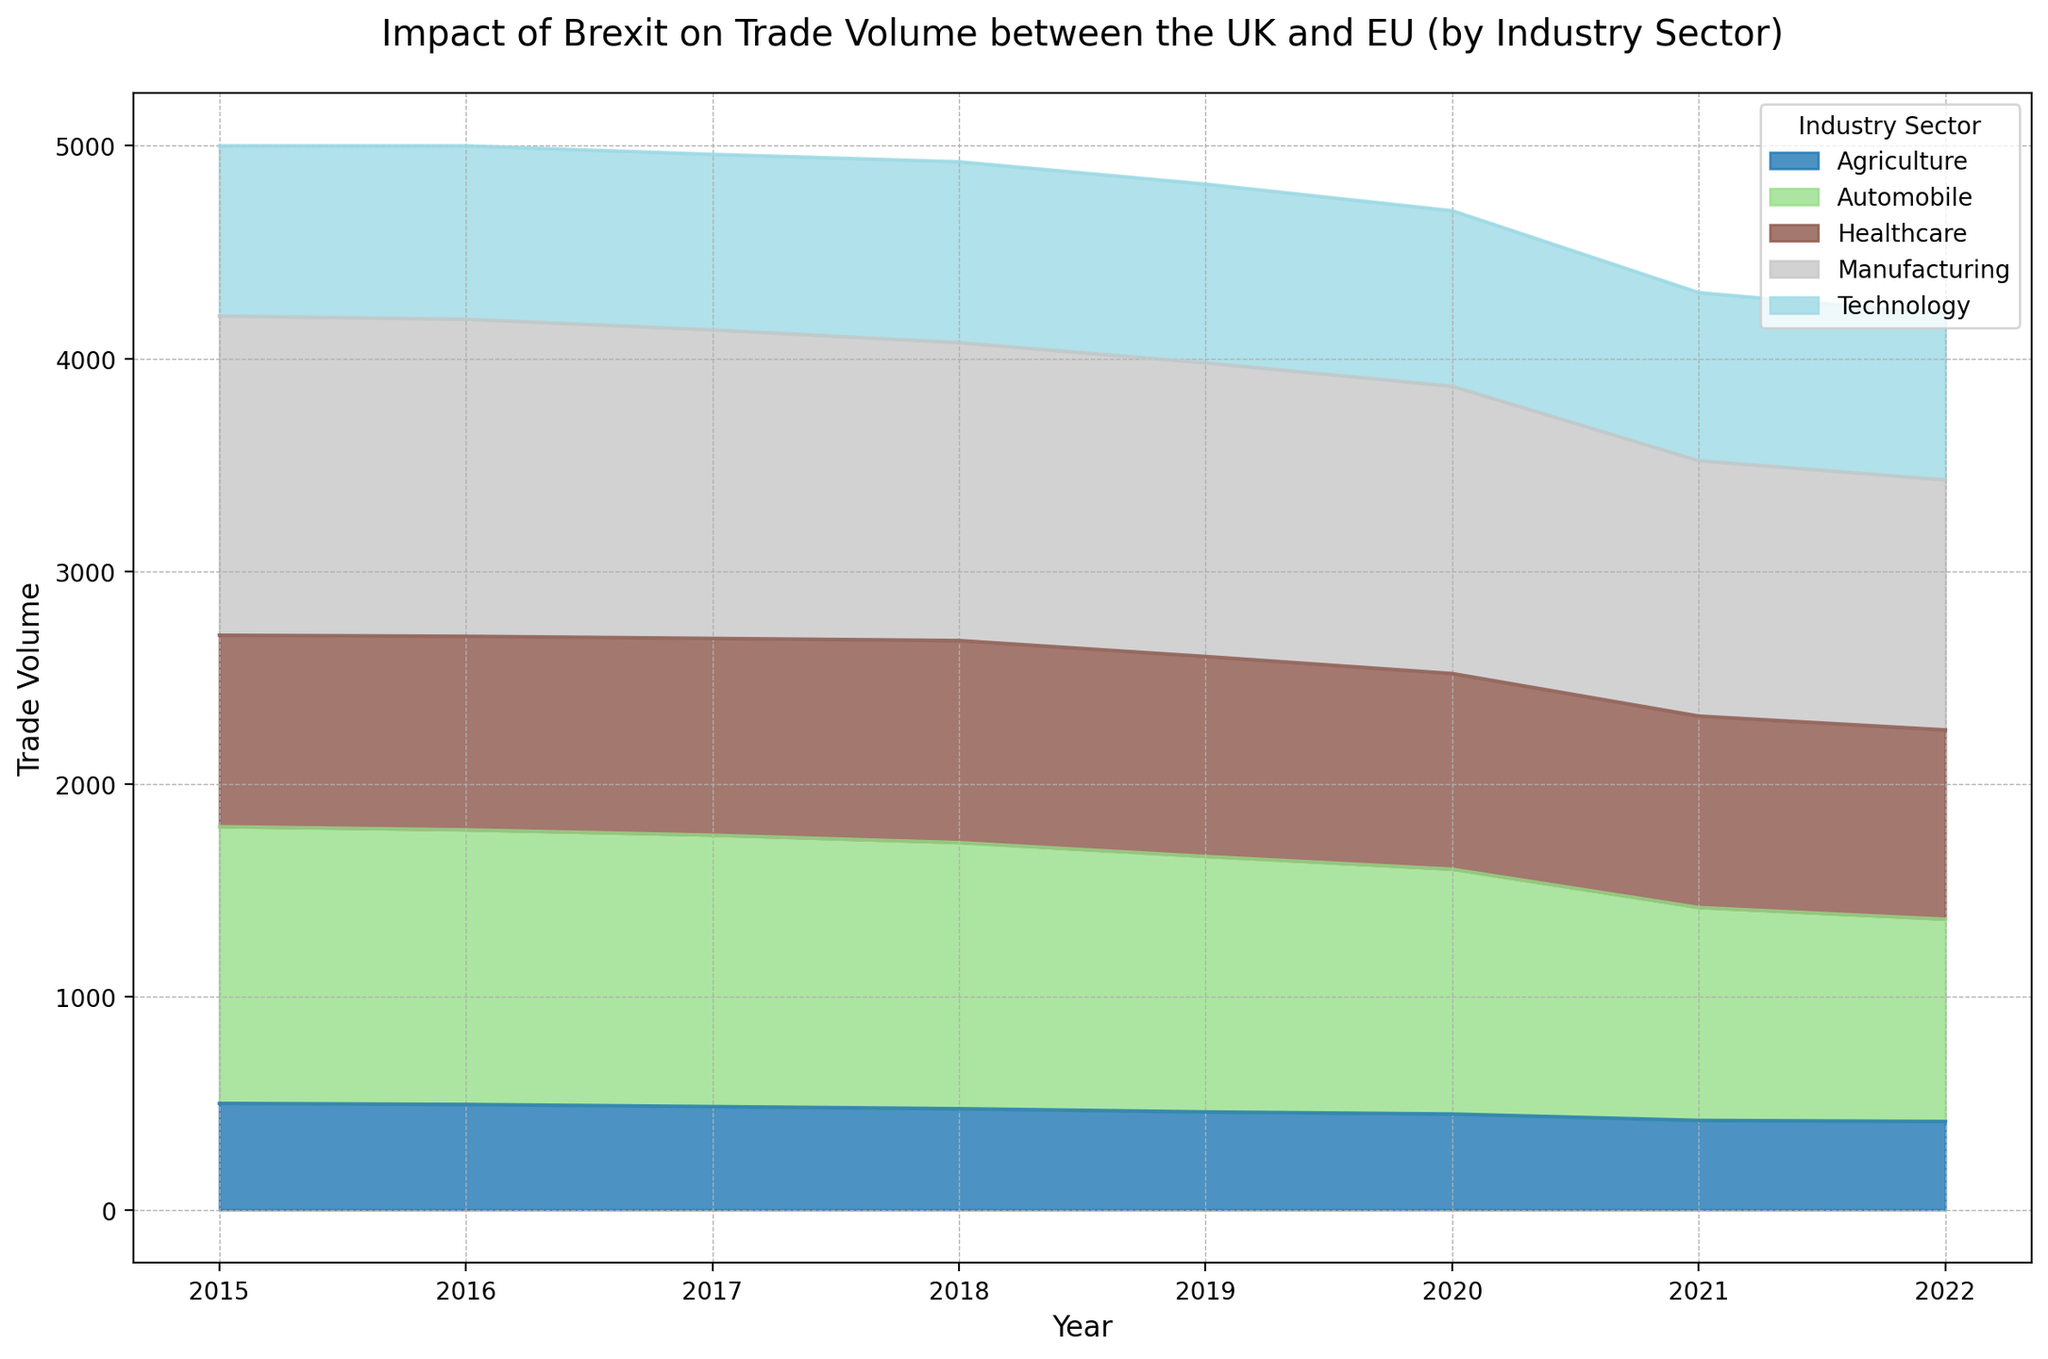What year did Agriculture experience the most significant drop in trade volume? Looking at the area representing Agriculture, the biggest drop occurs between 2020 and 2021. In 2020, the trade volume is 450, and in 2021 it drops to 420, a reduction of 30 units.
Answer: 2021 Which industry sector had the highest trade volume consistently over the years? By examining the cumulative height of the areas stacked in the chart, Manufacturing consistently appears on top, indicating it had the highest trade volume each year.
Answer: Manufacturing In which year did the Technology sector start to decline in trade volume? Observing the area chart for Technology, the trade volume starts to decline after 2019. The line decreases from 2019 to 2020.
Answer: 2020 What is the combined trade volume of Healthcare and Automobile sectors in 2019? From the chart, add the trade volumes of Healthcare and Automobile in 2019. Healthcare is 940 and Automobile is 1200, so 940 + 1200 = 2140.
Answer: 2140 Which industry sector had the least trade volume in 2022? Looking at the smallest segment at the top of the stacked area for 2022, Agriculture is the least with the lowest height.
Answer: Agriculture Did any industry sector experience an increase in trade volume in 2021 compared to 2020? By examining the changes between 2020 and 2021, no sectors seem to have an increased area. All appear to decrease or remain the same.
Answer: No What distinct color represents the Healthcare sector in the chart? Observing the chart's legend, Healthcare is represented by a specific area with a unique color. You can determine its distinct color from the visual representation.
Answer: Depends on the chart's color scheme; let's assume it's blue How does the total trade volume compare in 2015 and 2022? Sum the trade volumes of all sectors for 2015 and 2022 and then compare them. For simplicity, adding approximate values shows a decrease as all sectors primarily decreased over years, with fewer total in 2022.
Answer: Decrease How does the decline in trade volume between 2020 and 2021 compare with the overall trend from 2015-2022 for the Automobile sector? The decline from 2020 to 2021 in the Automobile sector is substantial, from 1150 to 1000, a reduction of 150 units. This one-year change is part of the overall downward trend from 1300 in 2015 to 950 in 2022.
Answer: The trend is consistent with an overall decline Which two sectors have the closest trade volumes in 2017? Observing the areas' heights for 2017, Technology and Healthcare have volumes closest together, as their areas appear almost the same in size.
Answer: Technology and Healthcare 